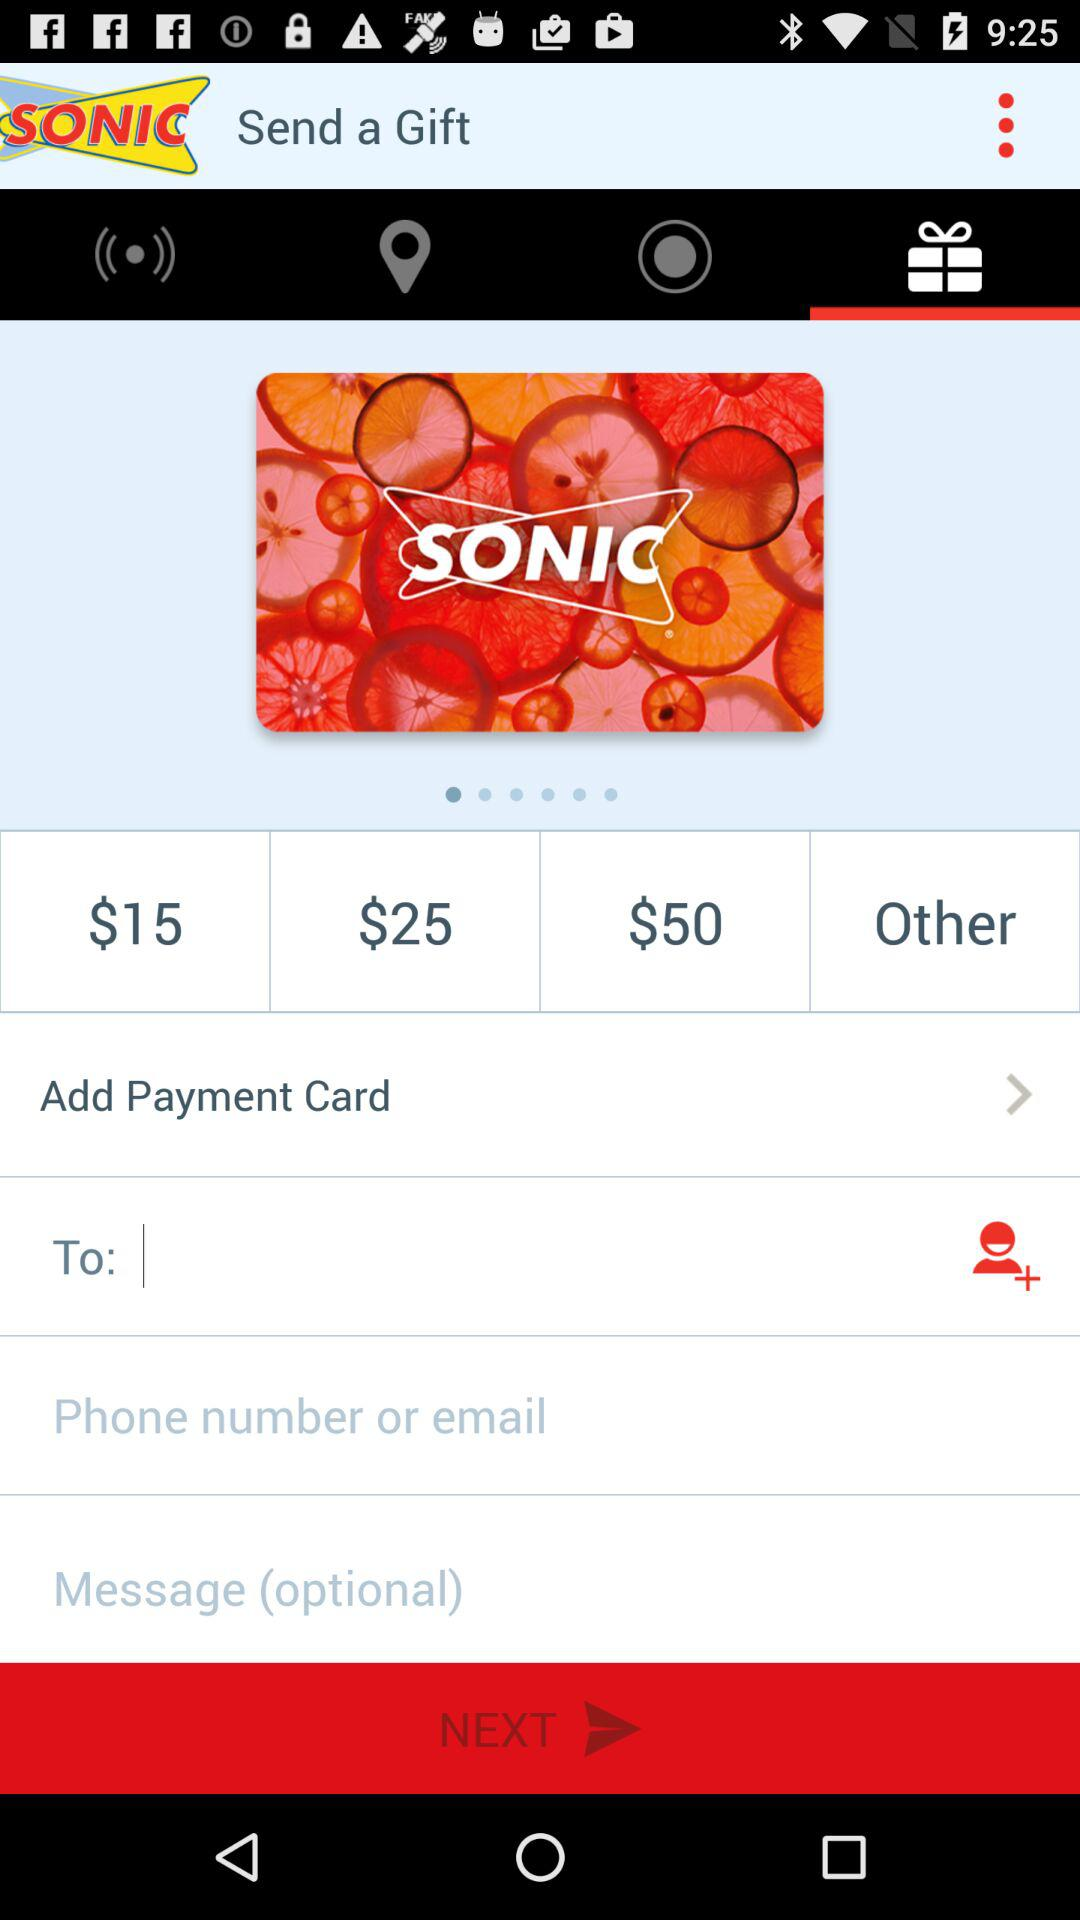What is the maximum cost of the gift? The maximum cost of the gift is $50. 